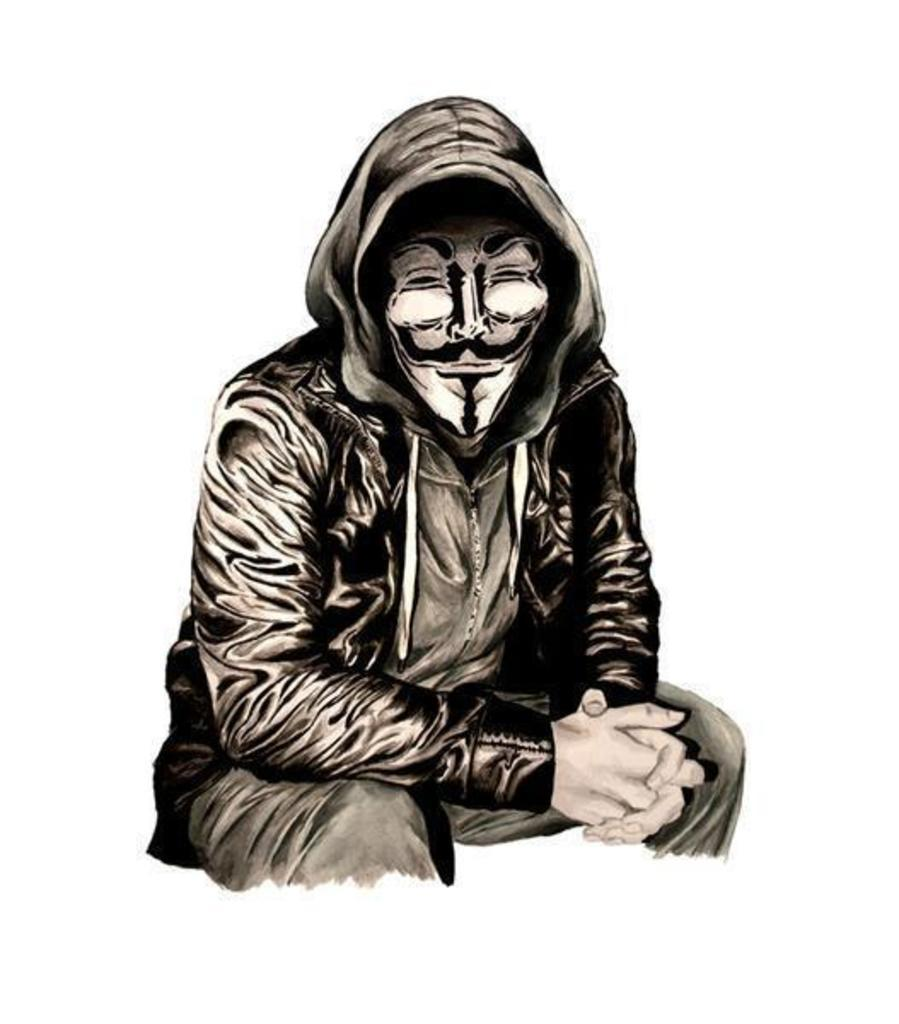What is the main subject of the image? There is a painting in the image. What is depicted in the painting? The painting is of a person. What color scheme is used in the painting? The painting is in black and white color. What is the color of the background in the painting? The background of the painting is white. What type of pest can be seen crawling on the painting in the image? There are no pests visible on the painting in the image. How many minutes does it take for the person in the painting to blink? The painting is a static image, so it is not possible to determine how long it takes for the person to blink. 